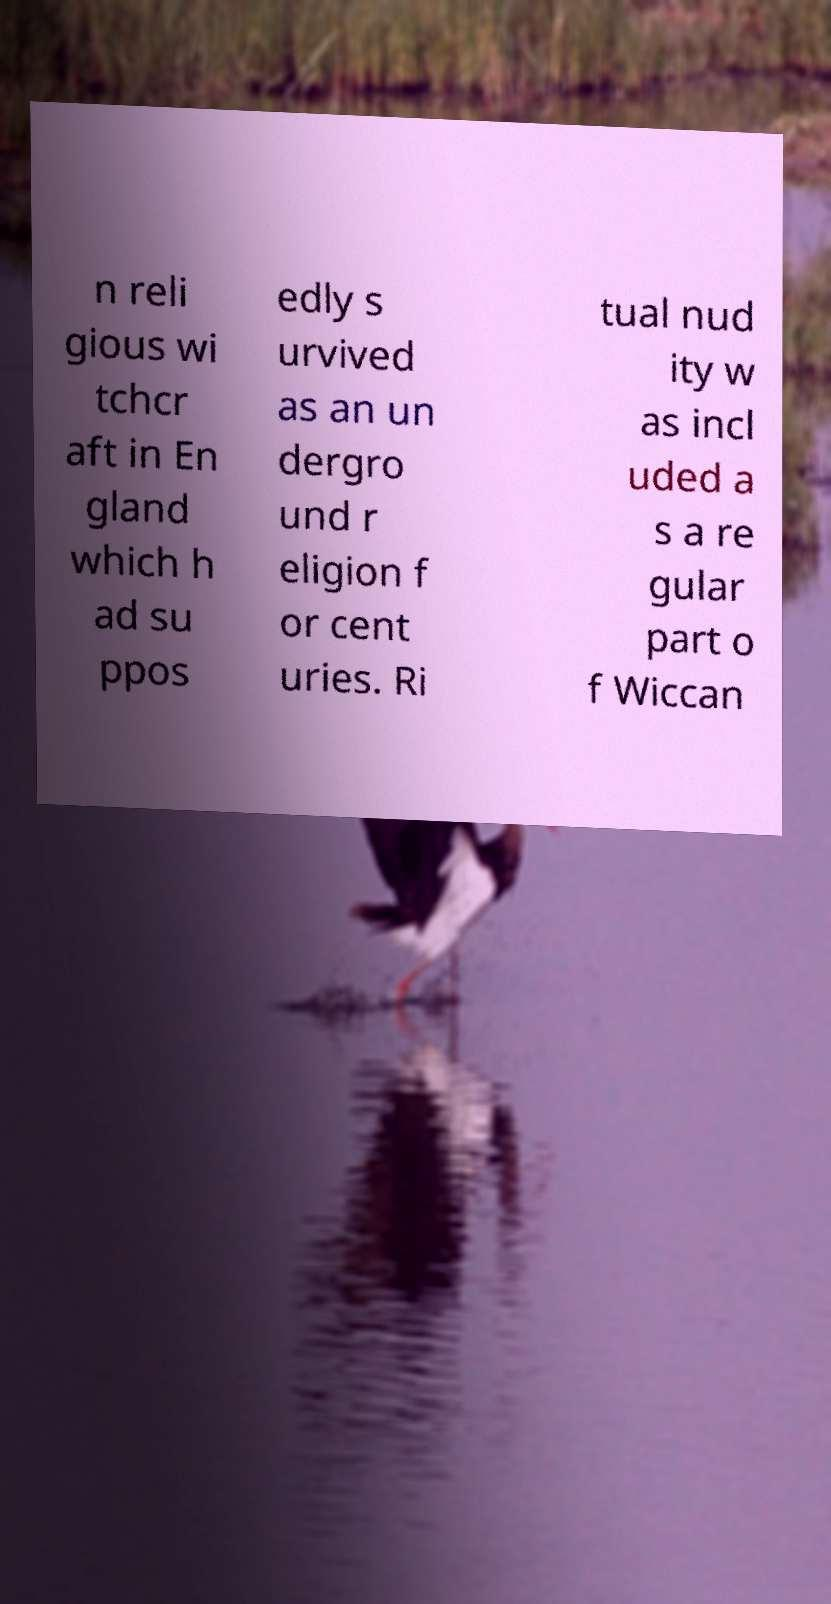Could you assist in decoding the text presented in this image and type it out clearly? n reli gious wi tchcr aft in En gland which h ad su ppos edly s urvived as an un dergro und r eligion f or cent uries. Ri tual nud ity w as incl uded a s a re gular part o f Wiccan 